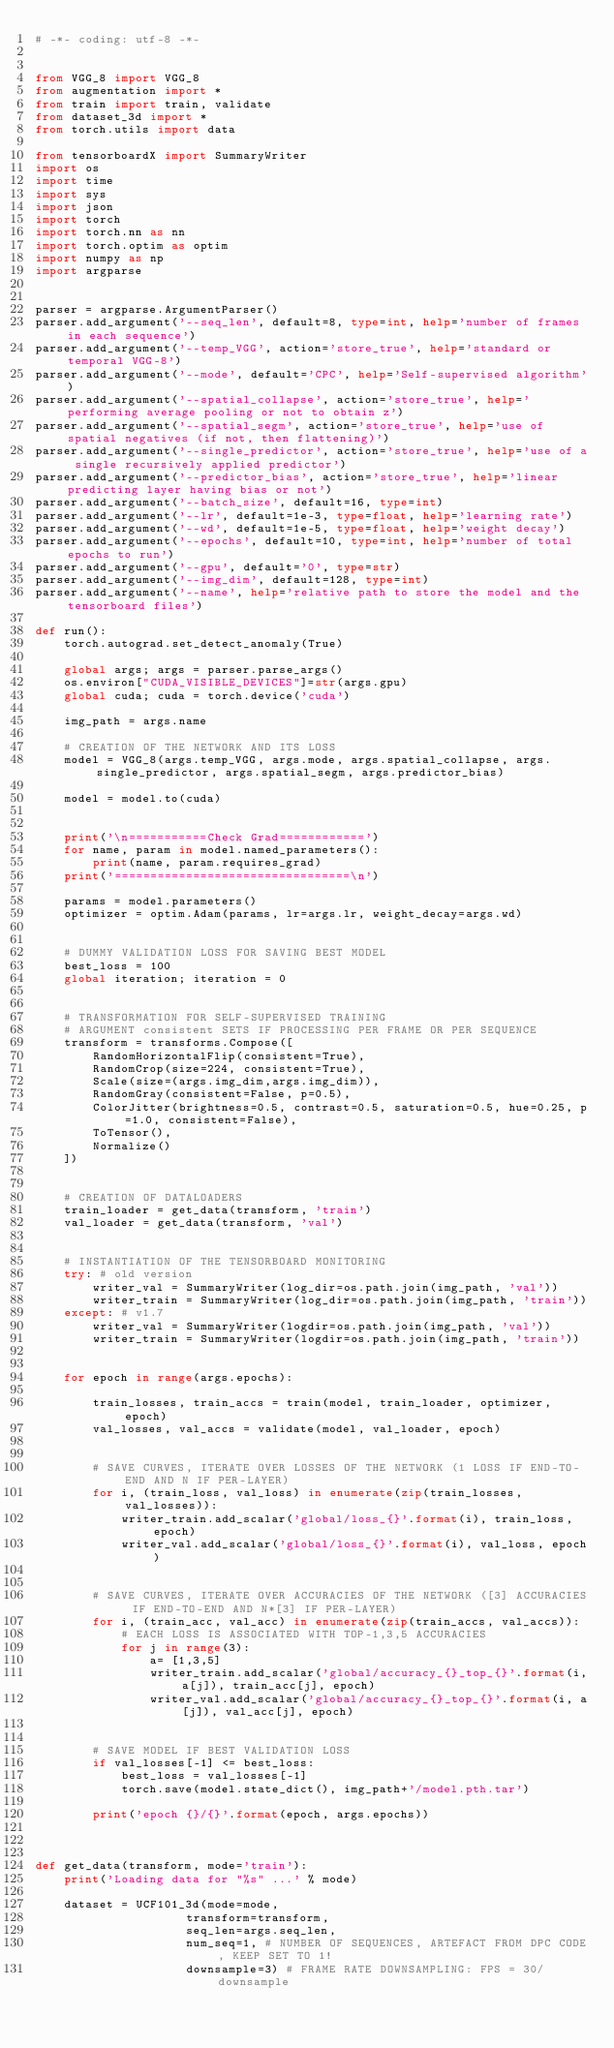Convert code to text. <code><loc_0><loc_0><loc_500><loc_500><_Python_># -*- coding: utf-8 -*-


from VGG_8 import VGG_8
from augmentation import *
from train import train, validate
from dataset_3d import *
from torch.utils import data

from tensorboardX import SummaryWriter
import os
import time
import sys
import json
import torch
import torch.nn as nn
import torch.optim as optim
import numpy as np
import argparse


parser = argparse.ArgumentParser()
parser.add_argument('--seq_len', default=8, type=int, help='number of frames in each sequence')
parser.add_argument('--temp_VGG', action='store_true', help='standard or temporal VGG-8')
parser.add_argument('--mode', default='CPC', help='Self-supervised algorithm')
parser.add_argument('--spatial_collapse', action='store_true', help='performing average pooling or not to obtain z')
parser.add_argument('--spatial_segm', action='store_true', help='use of spatial negatives (if not, then flattening)')
parser.add_argument('--single_predictor', action='store_true', help='use of a single recursively applied predictor')
parser.add_argument('--predictor_bias', action='store_true', help='linear predicting layer having bias or not')
parser.add_argument('--batch_size', default=16, type=int)
parser.add_argument('--lr', default=1e-3, type=float, help='learning rate')
parser.add_argument('--wd', default=1e-5, type=float, help='weight decay')
parser.add_argument('--epochs', default=10, type=int, help='number of total epochs to run')
parser.add_argument('--gpu', default='0', type=str)
parser.add_argument('--img_dim', default=128, type=int)
parser.add_argument('--name', help='relative path to store the model and the tensorboard files')

def run():    
    torch.autograd.set_detect_anomaly(True)

    global args; args = parser.parse_args()
    os.environ["CUDA_VISIBLE_DEVICES"]=str(args.gpu)
    global cuda; cuda = torch.device('cuda')
    
    img_path = args.name

    # CREATION OF THE NETWORK AND ITS LOSS
    model = VGG_8(args.temp_VGG, args.mode, args.spatial_collapse, args.single_predictor, args.spatial_segm, args.predictor_bias) 

    model = model.to(cuda)


    print('\n===========Check Grad============')
    for name, param in model.named_parameters():
        print(name, param.requires_grad)
    print('=================================\n')

    params = model.parameters()
    optimizer = optim.Adam(params, lr=args.lr, weight_decay=args.wd)


    # DUMMY VALIDATION LOSS FOR SAVING BEST MODEL 
    best_loss = 100
    global iteration; iteration = 0


    # TRANSFORMATION FOR SELF-SUPERVISED TRAINING
    # ARGUMENT consistent SETS IF PROCESSING PER FRAME OR PER SEQUENCE
    transform = transforms.Compose([
        RandomHorizontalFlip(consistent=True),
        RandomCrop(size=224, consistent=True),
        Scale(size=(args.img_dim,args.img_dim)),
        RandomGray(consistent=False, p=0.5),
        ColorJitter(brightness=0.5, contrast=0.5, saturation=0.5, hue=0.25, p=1.0, consistent=False),
        ToTensor(),
        Normalize()
    ])


    # CREATION OF DATALOADERS
    train_loader = get_data(transform, 'train')
    val_loader = get_data(transform, 'val')


    # INSTANTIATION OF THE TENSORBOARD MONITORING
    try: # old version
        writer_val = SummaryWriter(log_dir=os.path.join(img_path, 'val'))
        writer_train = SummaryWriter(log_dir=os.path.join(img_path, 'train'))
    except: # v1.7
        writer_val = SummaryWriter(logdir=os.path.join(img_path, 'val'))
        writer_train = SummaryWriter(logdir=os.path.join(img_path, 'train'))
        
        
    for epoch in range(args.epochs):
        
        train_losses, train_accs = train(model, train_loader, optimizer, epoch)
        val_losses, val_accs = validate(model, val_loader, epoch)


        # SAVE CURVES, ITERATE OVER LOSSES OF THE NETWORK (1 LOSS IF END-TO-END AND N IF PER-LAYER)
        for i, (train_loss, val_loss) in enumerate(zip(train_losses, val_losses)):
            writer_train.add_scalar('global/loss_{}'.format(i), train_loss, epoch)
            writer_val.add_scalar('global/loss_{}'.format(i), val_loss, epoch)
        
        
        # SAVE CURVES, ITERATE OVER ACCURACIES OF THE NETWORK ([3] ACCURACIES IF END-TO-END AND N*[3] IF PER-LAYER)
        for i, (train_acc, val_acc) in enumerate(zip(train_accs, val_accs)):
            # EACH LOSS IS ASSOCIATED WITH TOP-1,3,5 ACCURACIES  
            for j in range(3):
                a= [1,3,5]
                writer_train.add_scalar('global/accuracy_{}_top_{}'.format(i,a[j]), train_acc[j], epoch)
                writer_val.add_scalar('global/accuracy_{}_top_{}'.format(i, a[j]), val_acc[j], epoch)
               
                
        # SAVE MODEL IF BEST VALIDATION LOSS
        if val_losses[-1] <= best_loss:
            best_loss = val_losses[-1]
            torch.save(model.state_dict(), img_path+'/model.pth.tar')
            
        print('epoch {}/{}'.format(epoch, args.epochs))
        
        
        
def get_data(transform, mode='train'):
    print('Loading data for "%s" ...' % mode)

    dataset = UCF101_3d(mode=mode,
                     transform=transform,
                     seq_len=args.seq_len,
                     num_seq=1, # NUMBER OF SEQUENCES, ARTEFACT FROM DPC CODE, KEEP SET TO 1! 
                     downsample=3) # FRAME RATE DOWNSAMPLING: FPS = 30/downsample</code> 